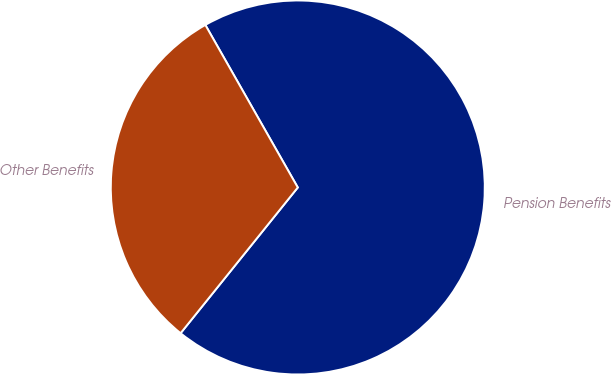<chart> <loc_0><loc_0><loc_500><loc_500><pie_chart><fcel>Pension Benefits<fcel>Other Benefits<nl><fcel>69.01%<fcel>30.99%<nl></chart> 